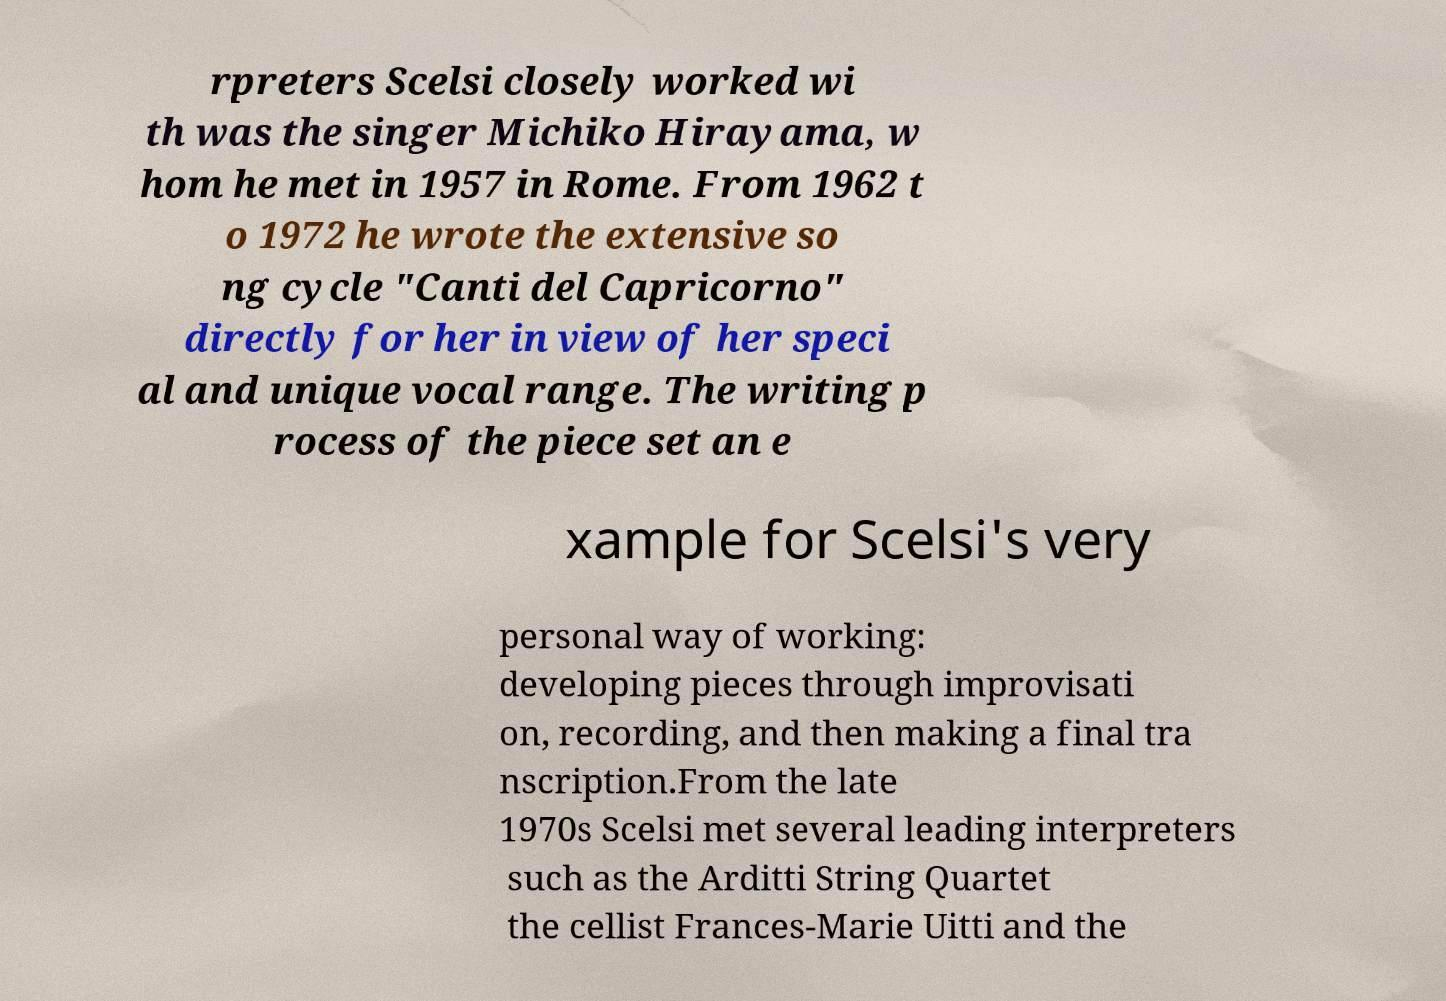For documentation purposes, I need the text within this image transcribed. Could you provide that? rpreters Scelsi closely worked wi th was the singer Michiko Hirayama, w hom he met in 1957 in Rome. From 1962 t o 1972 he wrote the extensive so ng cycle "Canti del Capricorno" directly for her in view of her speci al and unique vocal range. The writing p rocess of the piece set an e xample for Scelsi's very personal way of working: developing pieces through improvisati on, recording, and then making a final tra nscription.From the late 1970s Scelsi met several leading interpreters such as the Arditti String Quartet the cellist Frances-Marie Uitti and the 